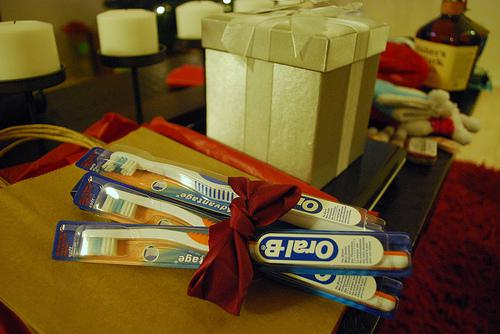Question: what is shown in the picture?
Choices:
A. Gifts.
B. Toys.
C. Jewelry.
D. Cards.
Answer with the letter. Answer: A Question: where is the box?
Choices:
A. On the table.
B. On the bed.
C. Behind toothbrushes.
D. Near the window.
Answer with the letter. Answer: C Question: how many toothbrushes are there?
Choices:
A. Two.
B. One.
C. Four.
D. Three.
Answer with the letter. Answer: D 